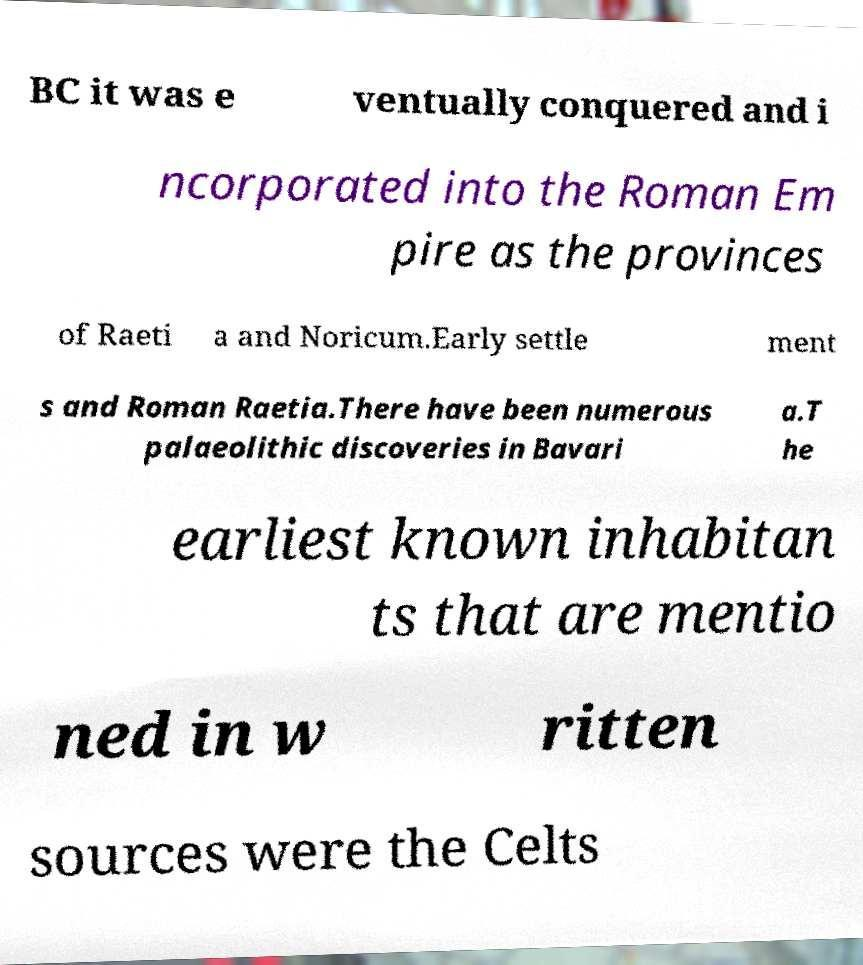Could you extract and type out the text from this image? BC it was e ventually conquered and i ncorporated into the Roman Em pire as the provinces of Raeti a and Noricum.Early settle ment s and Roman Raetia.There have been numerous palaeolithic discoveries in Bavari a.T he earliest known inhabitan ts that are mentio ned in w ritten sources were the Celts 